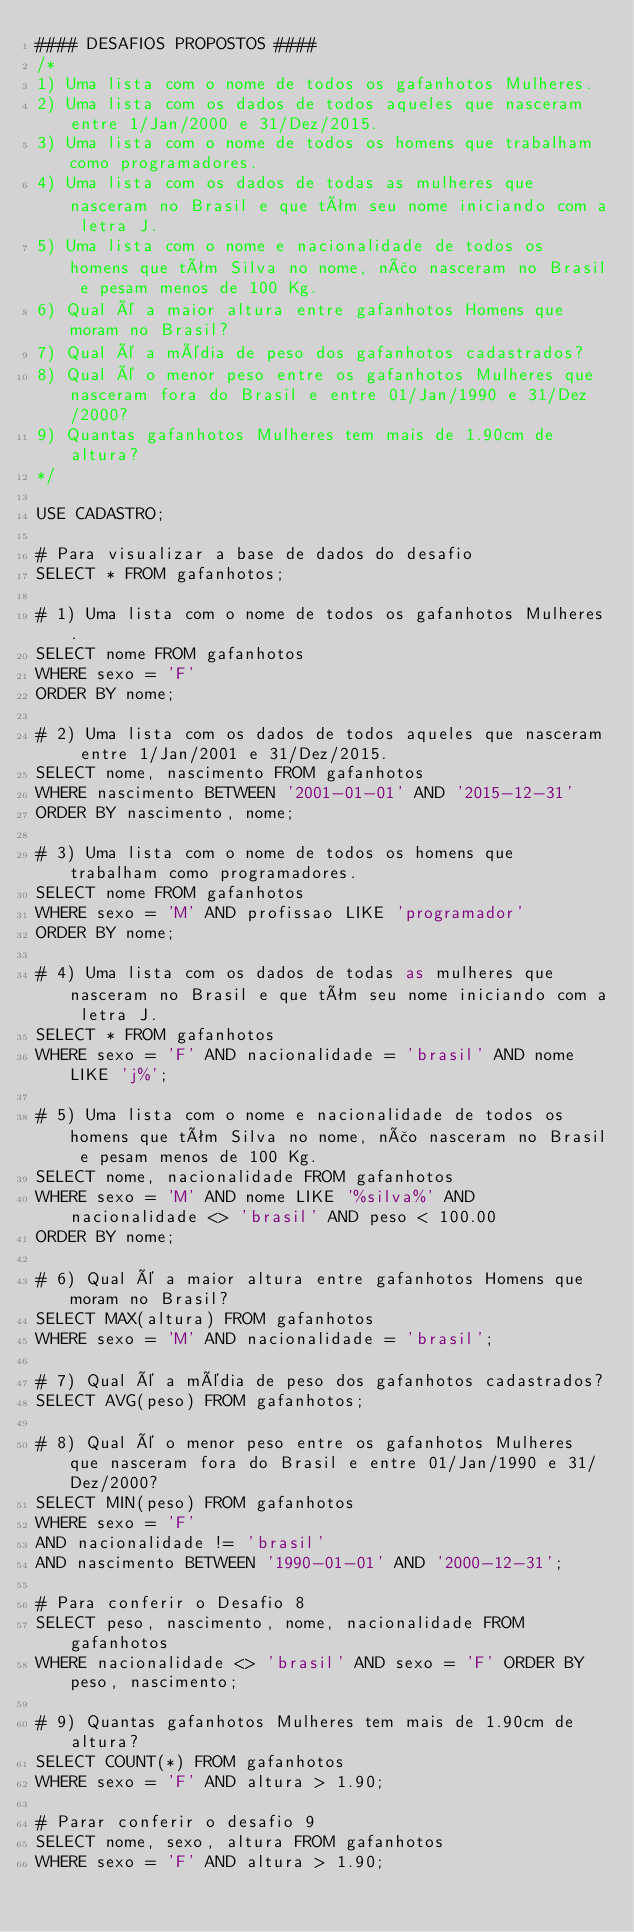<code> <loc_0><loc_0><loc_500><loc_500><_SQL_>#### DESAFIOS PROPOSTOS ####
/*
1) Uma lista com o nome de todos os gafanhotos Mulheres.
2) Uma lista com os dados de todos aqueles que nasceram entre 1/Jan/2000 e 31/Dez/2015.
3) Uma lista com o nome de todos os homens que trabalham como programadores.
4) Uma lista com os dados de todas as mulheres que nasceram no Brasil e que têm seu nome iniciando com a letra J.
5) Uma lista com o nome e nacionalidade de todos os homens que têm Silva no nome, não nasceram no Brasil e pesam menos de 100 Kg.
6) Qual é a maior altura entre gafanhotos Homens que moram no Brasil?
7) Qual é a média de peso dos gafanhotos cadastrados?
8) Qual é o menor peso entre os gafanhotos Mulheres que nasceram fora do Brasil e entre 01/Jan/1990 e 31/Dez/2000?
9) Quantas gafanhotos Mulheres tem mais de 1.90cm de altura?
*/

USE CADASTRO;

# Para visualizar a base de dados do desafio
SELECT * FROM gafanhotos;

# 1) Uma lista com o nome de todos os gafanhotos Mulheres.
SELECT nome FROM gafanhotos 
WHERE sexo = 'F'
ORDER BY nome;

# 2) Uma lista com os dados de todos aqueles que nasceram entre 1/Jan/2001 e 31/Dez/2015.
SELECT nome, nascimento FROM gafanhotos 
WHERE nascimento BETWEEN '2001-01-01' AND '2015-12-31'
ORDER BY nascimento, nome;

# 3) Uma lista com o nome de todos os homens que trabalham como programadores.
SELECT nome FROM gafanhotos 
WHERE sexo = 'M' AND profissao LIKE 'programador' 
ORDER BY nome;

# 4) Uma lista com os dados de todas as mulheres que nasceram no Brasil e que têm seu nome iniciando com a letra J.
SELECT * FROM gafanhotos 
WHERE sexo = 'F' AND nacionalidade = 'brasil' AND nome LIKE 'j%';

# 5) Uma lista com o nome e nacionalidade de todos os homens que têm Silva no nome, não nasceram no Brasil e pesam menos de 100 Kg.
SELECT nome, nacionalidade FROM gafanhotos 
WHERE sexo = 'M' AND nome LIKE '%silva%' AND nacionalidade <> 'brasil' AND peso < 100.00 
ORDER BY nome;

# 6) Qual é a maior altura entre gafanhotos Homens que moram no Brasil?
SELECT MAX(altura) FROM gafanhotos 
WHERE sexo = 'M' AND nacionalidade = 'brasil';

# 7) Qual é a média de peso dos gafanhotos cadastrados?
SELECT AVG(peso) FROM gafanhotos;

# 8) Qual é o menor peso entre os gafanhotos Mulheres que nasceram fora do Brasil e entre 01/Jan/1990 e 31/Dez/2000?
SELECT MIN(peso) FROM gafanhotos 
WHERE sexo = 'F' 
AND nacionalidade != 'brasil' 
AND nascimento BETWEEN '1990-01-01' AND '2000-12-31';

# Para conferir o Desafio 8
SELECT peso, nascimento, nome, nacionalidade FROM gafanhotos 
WHERE nacionalidade <> 'brasil' AND sexo = 'F' ORDER BY peso, nascimento;

# 9) Quantas gafanhotos Mulheres tem mais de 1.90cm de altura?
SELECT COUNT(*) FROM gafanhotos 
WHERE sexo = 'F' AND altura > 1.90;

# Parar conferir o desafio 9
SELECT nome, sexo, altura FROM gafanhotos 
WHERE sexo = 'F' AND altura > 1.90;</code> 